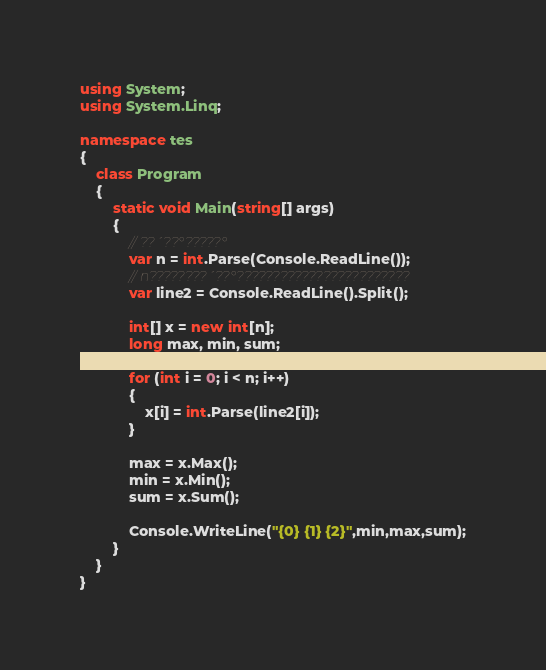Convert code to text. <code><loc_0><loc_0><loc_500><loc_500><_C#_>using System;
using System.Linq;

namespace tes
{
    class Program
    {
        static void Main(string[] args)
        {
            // ??´??°?????°
            var n = int.Parse(Console.ReadLine());
            // n????????´??°????????????????????????
            var line2 = Console.ReadLine().Split();
            
            int[] x = new int[n];
            long max, min, sum;

            for (int i = 0; i < n; i++)
            {
                x[i] = int.Parse(line2[i]);
            }

            max = x.Max();
            min = x.Min();
            sum = x.Sum();

            Console.WriteLine("{0} {1} {2}",min,max,sum);
        }
    }
}</code> 